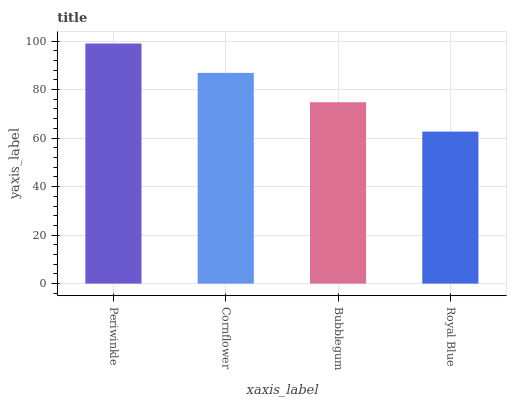Is Royal Blue the minimum?
Answer yes or no. Yes. Is Periwinkle the maximum?
Answer yes or no. Yes. Is Cornflower the minimum?
Answer yes or no. No. Is Cornflower the maximum?
Answer yes or no. No. Is Periwinkle greater than Cornflower?
Answer yes or no. Yes. Is Cornflower less than Periwinkle?
Answer yes or no. Yes. Is Cornflower greater than Periwinkle?
Answer yes or no. No. Is Periwinkle less than Cornflower?
Answer yes or no. No. Is Cornflower the high median?
Answer yes or no. Yes. Is Bubblegum the low median?
Answer yes or no. Yes. Is Royal Blue the high median?
Answer yes or no. No. Is Royal Blue the low median?
Answer yes or no. No. 